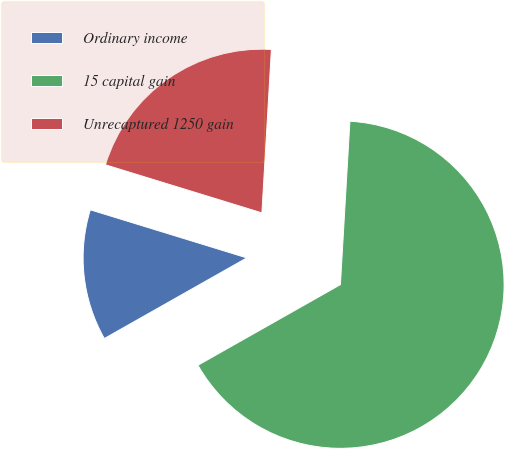Convert chart. <chart><loc_0><loc_0><loc_500><loc_500><pie_chart><fcel>Ordinary income<fcel>15 capital gain<fcel>Unrecaptured 1250 gain<nl><fcel>12.94%<fcel>65.88%<fcel>21.18%<nl></chart> 